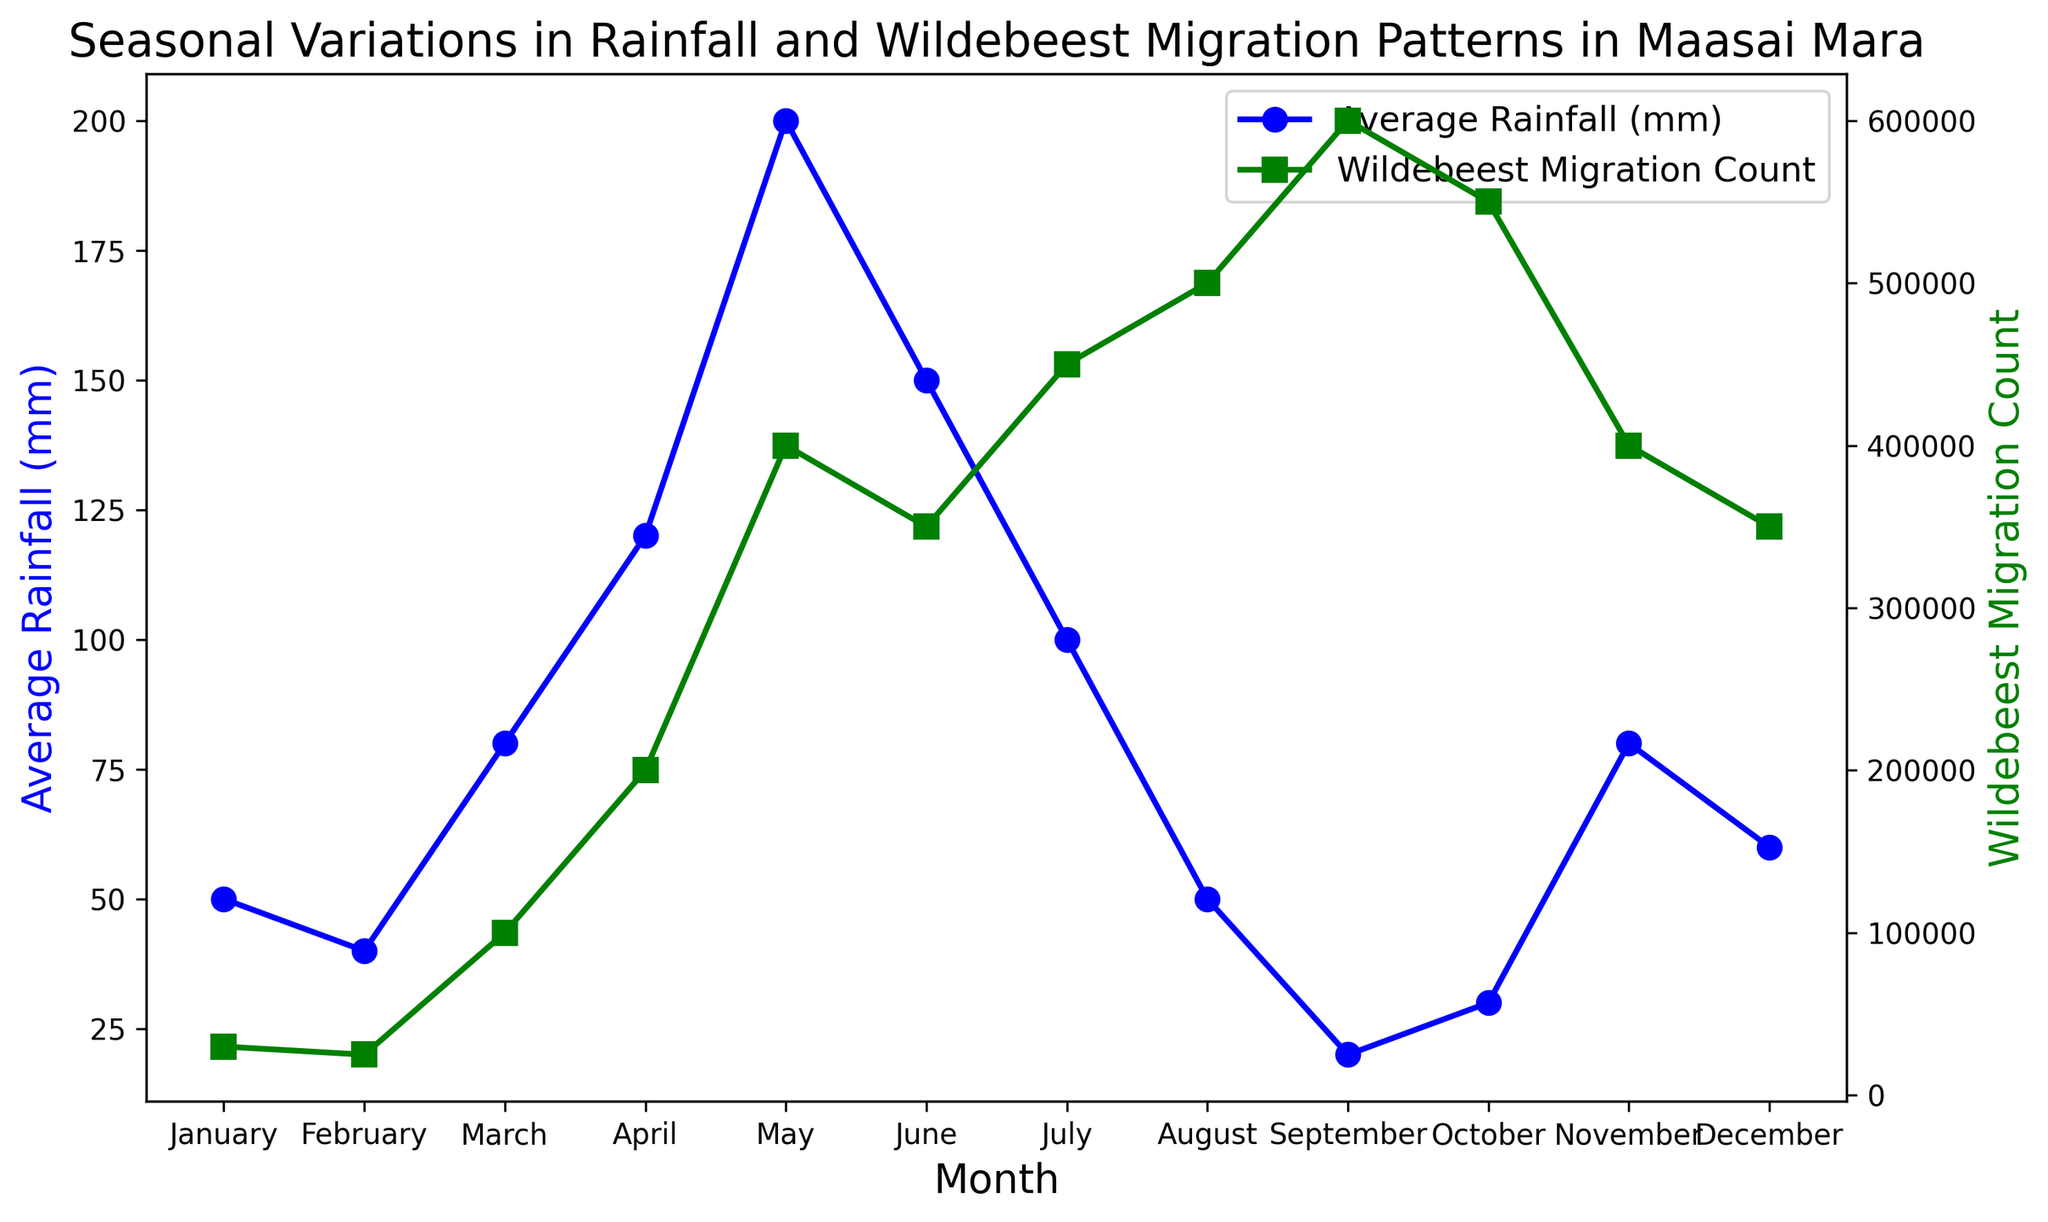What is the average rainfall in May? The average rainfall in May is directly given in the data, where it shows that May has 200mm of rainfall.
Answer: 200 mm Which month has the highest average rainfall, and what is its corresponding wildebeest migration count? From the chart, May has the highest average rainfall of 200 mm. Referring to the corresponding wildebeest migration count for May, it is 400,000.
Answer: May, 400,000 Is the wildebeest migration count higher in August or January, and by how much? The wildebeest migration count in August is 500,000 whereas in January it is 30,000. By subtracting these values, we find that the count is higher in August by 470,000 (500,000 - 30,000).
Answer: August, 470,000 What is the total wildebeest migration count for the months with average rainfall less than 50 mm? The months with average rainfall less than 50 mm are February (40 mm) and September (20 mm). Adding their wildebeest migration counts gives 25,000 (February) + 600,000 (September) = 625,000.
Answer: 625,000 How does the wildebeest migration count in September compare with April? In September, the wildebeest migration count is 600,000. In April, it is 200,000. 600,000 is greater than 200,000, so the count in September is higher by 400,000 (600,000 - 200,000).
Answer: Higher, 400,000 In which month do we observe the sharpest increase in the wildebeest migration count? By observing the figure, the sharpest increase can be seen between February and March, where the count jumps from 25,000 to 100,000.
Answer: Between February and March During which month is the average rainfall equal to 80 mm, and what is the corresponding wildebeest migration count for that month? The months with 80 mm of average rainfall are March and November. In March, the migration count is 100,000, and in November, it is 400,000.
Answer: March, 100,000; November, 400,000 What is the overall trend in the wildebeest migration count from January to September? From January to September, the wildebeest migration count shows a general increasing trend, starting at 30,000 in January and peaking at 600,000 in September.
Answer: Increasing trend Which month has the lowest average rainfall, and does it correspond to the highest or lowest wildebeest migration count? September has the lowest average rainfall of 20 mm and it corresponds to the highest wildebeest migration count of 600,000.
Answer: September, highest Calculate the average wildebeest migration count for the months with an average rainfall of over 100 mm. The months with average rainfall over 100 mm are April (120 mm) and May (200 mm), with migration counts of 200,000 and 400,000 respectively. The average is (200,000 + 400,000) / 2 = 300,000.
Answer: 300,000 